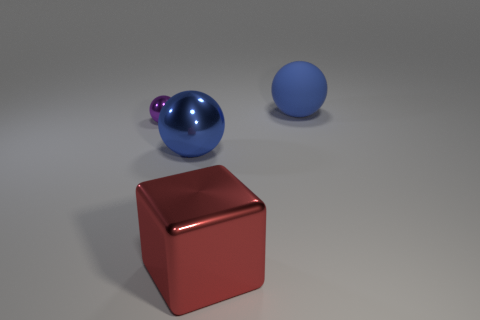What number of big gray shiny objects are there?
Your response must be concise. 0. What number of objects are red metal blocks or large balls that are in front of the tiny purple ball?
Offer a very short reply. 2. Is there any other thing that is the same shape as the red shiny object?
Your answer should be compact. No. There is a metal sphere in front of the purple sphere; is its size the same as the shiny block?
Give a very brief answer. Yes. What number of metal objects are either large brown objects or spheres?
Ensure brevity in your answer.  2. There is a sphere in front of the tiny purple metal sphere; what size is it?
Your response must be concise. Large. Are there an equal number of cyan things and red blocks?
Keep it short and to the point. No. Is the shape of the red thing the same as the purple metal object?
Give a very brief answer. No. How many big objects are either green metallic blocks or purple metallic objects?
Offer a very short reply. 0. There is a large blue shiny thing; are there any matte spheres in front of it?
Ensure brevity in your answer.  No. 